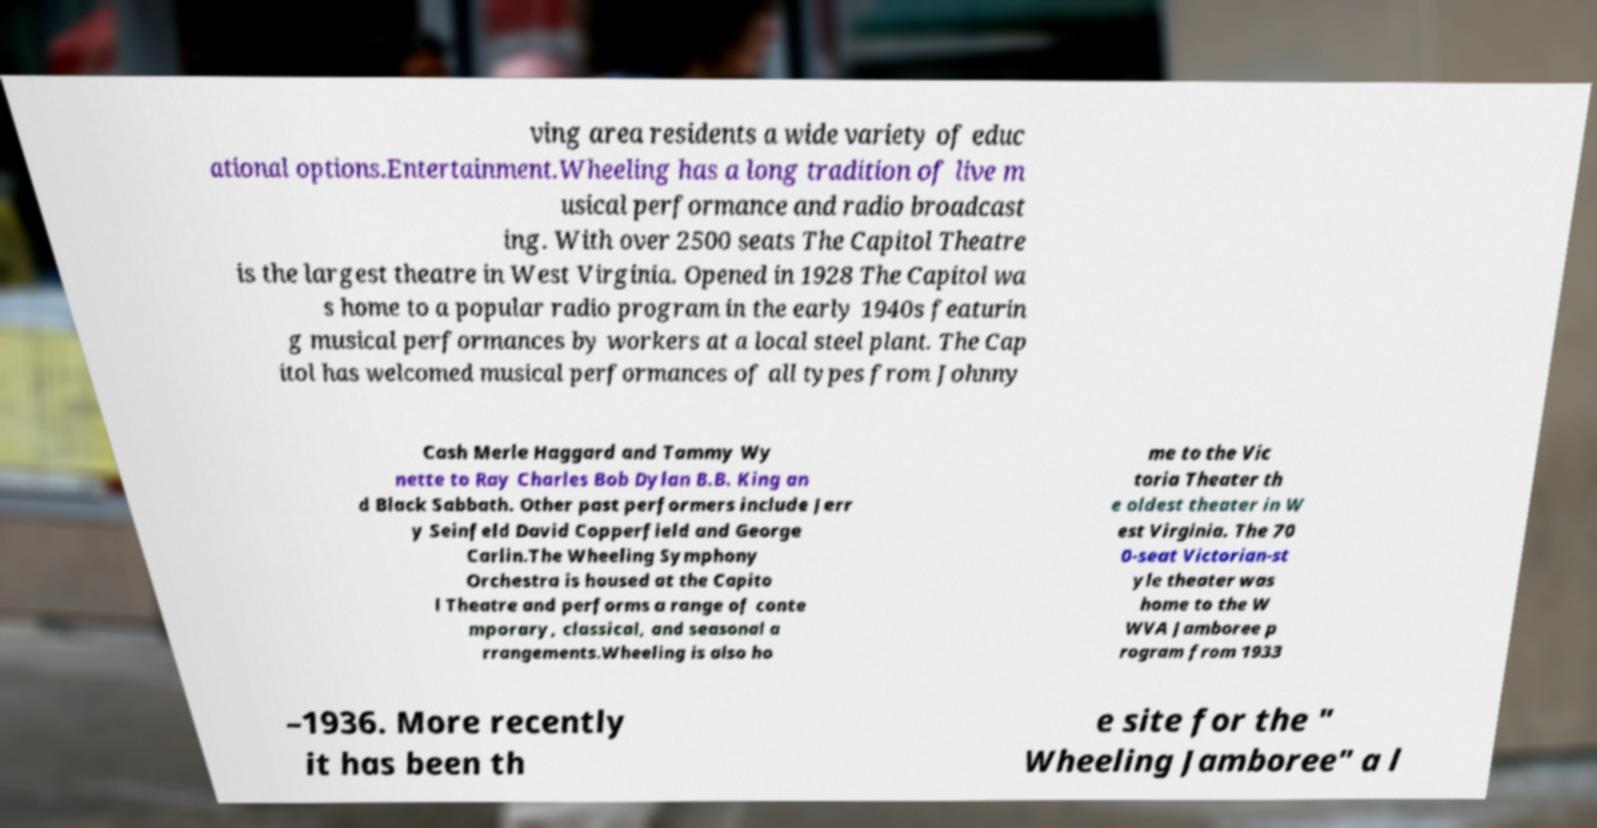For documentation purposes, I need the text within this image transcribed. Could you provide that? ving area residents a wide variety of educ ational options.Entertainment.Wheeling has a long tradition of live m usical performance and radio broadcast ing. With over 2500 seats The Capitol Theatre is the largest theatre in West Virginia. Opened in 1928 The Capitol wa s home to a popular radio program in the early 1940s featurin g musical performances by workers at a local steel plant. The Cap itol has welcomed musical performances of all types from Johnny Cash Merle Haggard and Tammy Wy nette to Ray Charles Bob Dylan B.B. King an d Black Sabbath. Other past performers include Jerr y Seinfeld David Copperfield and George Carlin.The Wheeling Symphony Orchestra is housed at the Capito l Theatre and performs a range of conte mporary, classical, and seasonal a rrangements.Wheeling is also ho me to the Vic toria Theater th e oldest theater in W est Virginia. The 70 0-seat Victorian-st yle theater was home to the W WVA Jamboree p rogram from 1933 –1936. More recently it has been th e site for the " Wheeling Jamboree" a l 